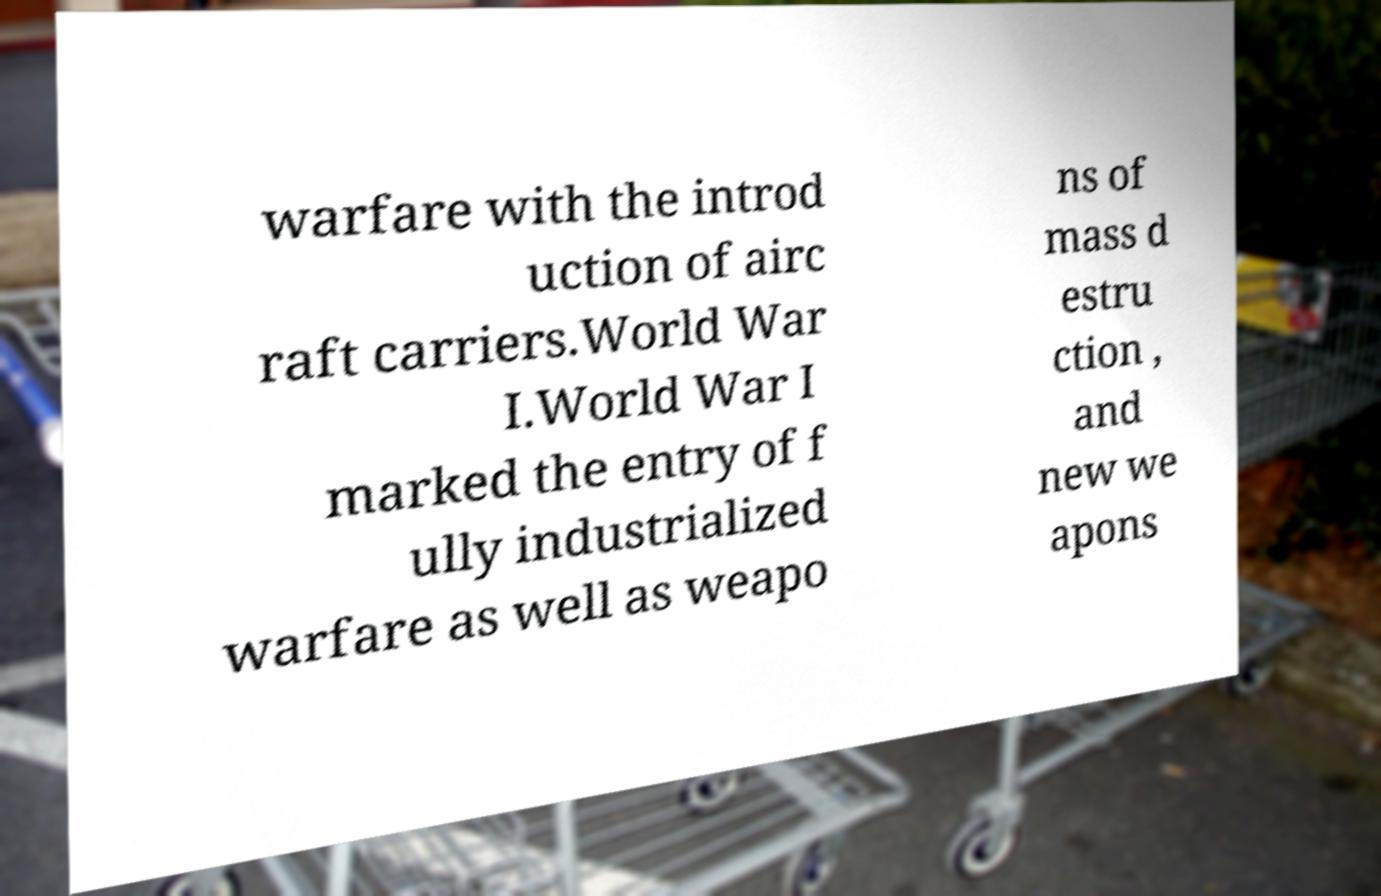Could you extract and type out the text from this image? warfare with the introd uction of airc raft carriers.World War I.World War I marked the entry of f ully industrialized warfare as well as weapo ns of mass d estru ction , and new we apons 